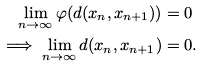Convert formula to latex. <formula><loc_0><loc_0><loc_500><loc_500>\lim _ { n \to \infty } \varphi ( d ( x _ { n } , x _ { n + 1 } ) ) & = 0 \\ \implies \lim _ { n \to \infty } d ( x _ { n } , x _ { n + 1 } ) & = 0 .</formula> 